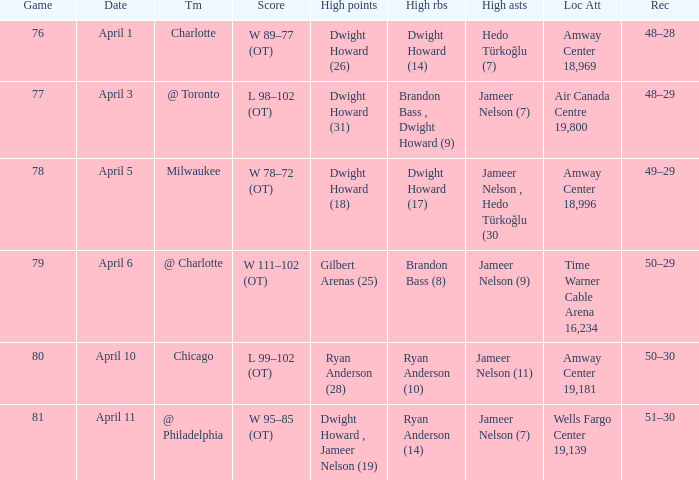Who had the most the most rebounds and how many did they have on April 1? Dwight Howard (14). 